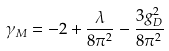Convert formula to latex. <formula><loc_0><loc_0><loc_500><loc_500>\gamma _ { M } = - 2 + \frac { \lambda } { 8 \pi ^ { 2 } } - \frac { 3 g _ { D } ^ { 2 } } { 8 \pi ^ { 2 } }</formula> 